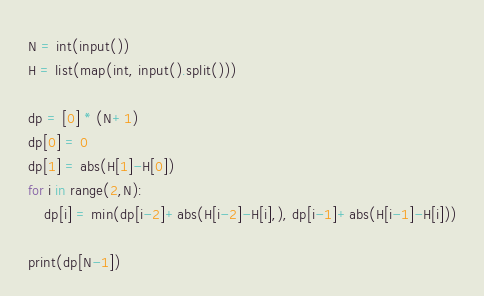<code> <loc_0><loc_0><loc_500><loc_500><_Python_>N = int(input())
H = list(map(int, input().split()))

dp = [0] * (N+1)
dp[0] = 0
dp[1] = abs(H[1]-H[0])
for i in range(2,N):
    dp[i] = min(dp[i-2]+abs(H[i-2]-H[i],), dp[i-1]+abs(H[i-1]-H[i]))

print(dp[N-1])</code> 